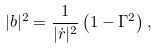Convert formula to latex. <formula><loc_0><loc_0><loc_500><loc_500>| { b } | ^ { 2 } = \frac { 1 } { | \dot { r } | ^ { 2 } } \left ( 1 - \Gamma ^ { 2 } \right ) ,</formula> 